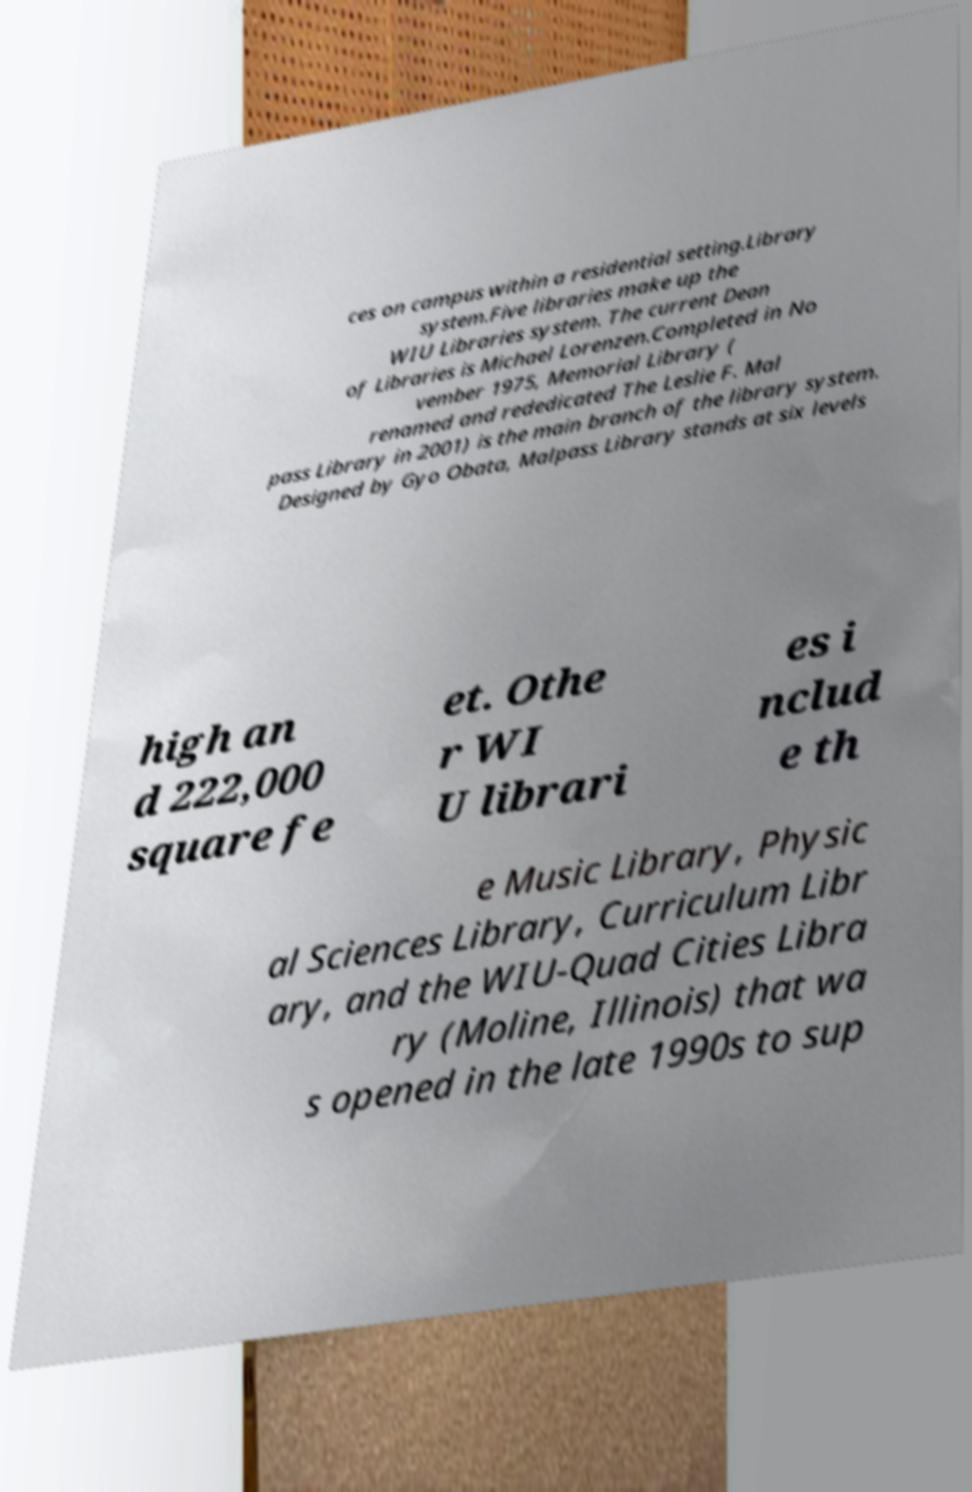Can you accurately transcribe the text from the provided image for me? ces on campus within a residential setting.Library system.Five libraries make up the WIU Libraries system. The current Dean of Libraries is Michael Lorenzen.Completed in No vember 1975, Memorial Library ( renamed and rededicated The Leslie F. Mal pass Library in 2001) is the main branch of the library system. Designed by Gyo Obata, Malpass Library stands at six levels high an d 222,000 square fe et. Othe r WI U librari es i nclud e th e Music Library, Physic al Sciences Library, Curriculum Libr ary, and the WIU-Quad Cities Libra ry (Moline, Illinois) that wa s opened in the late 1990s to sup 